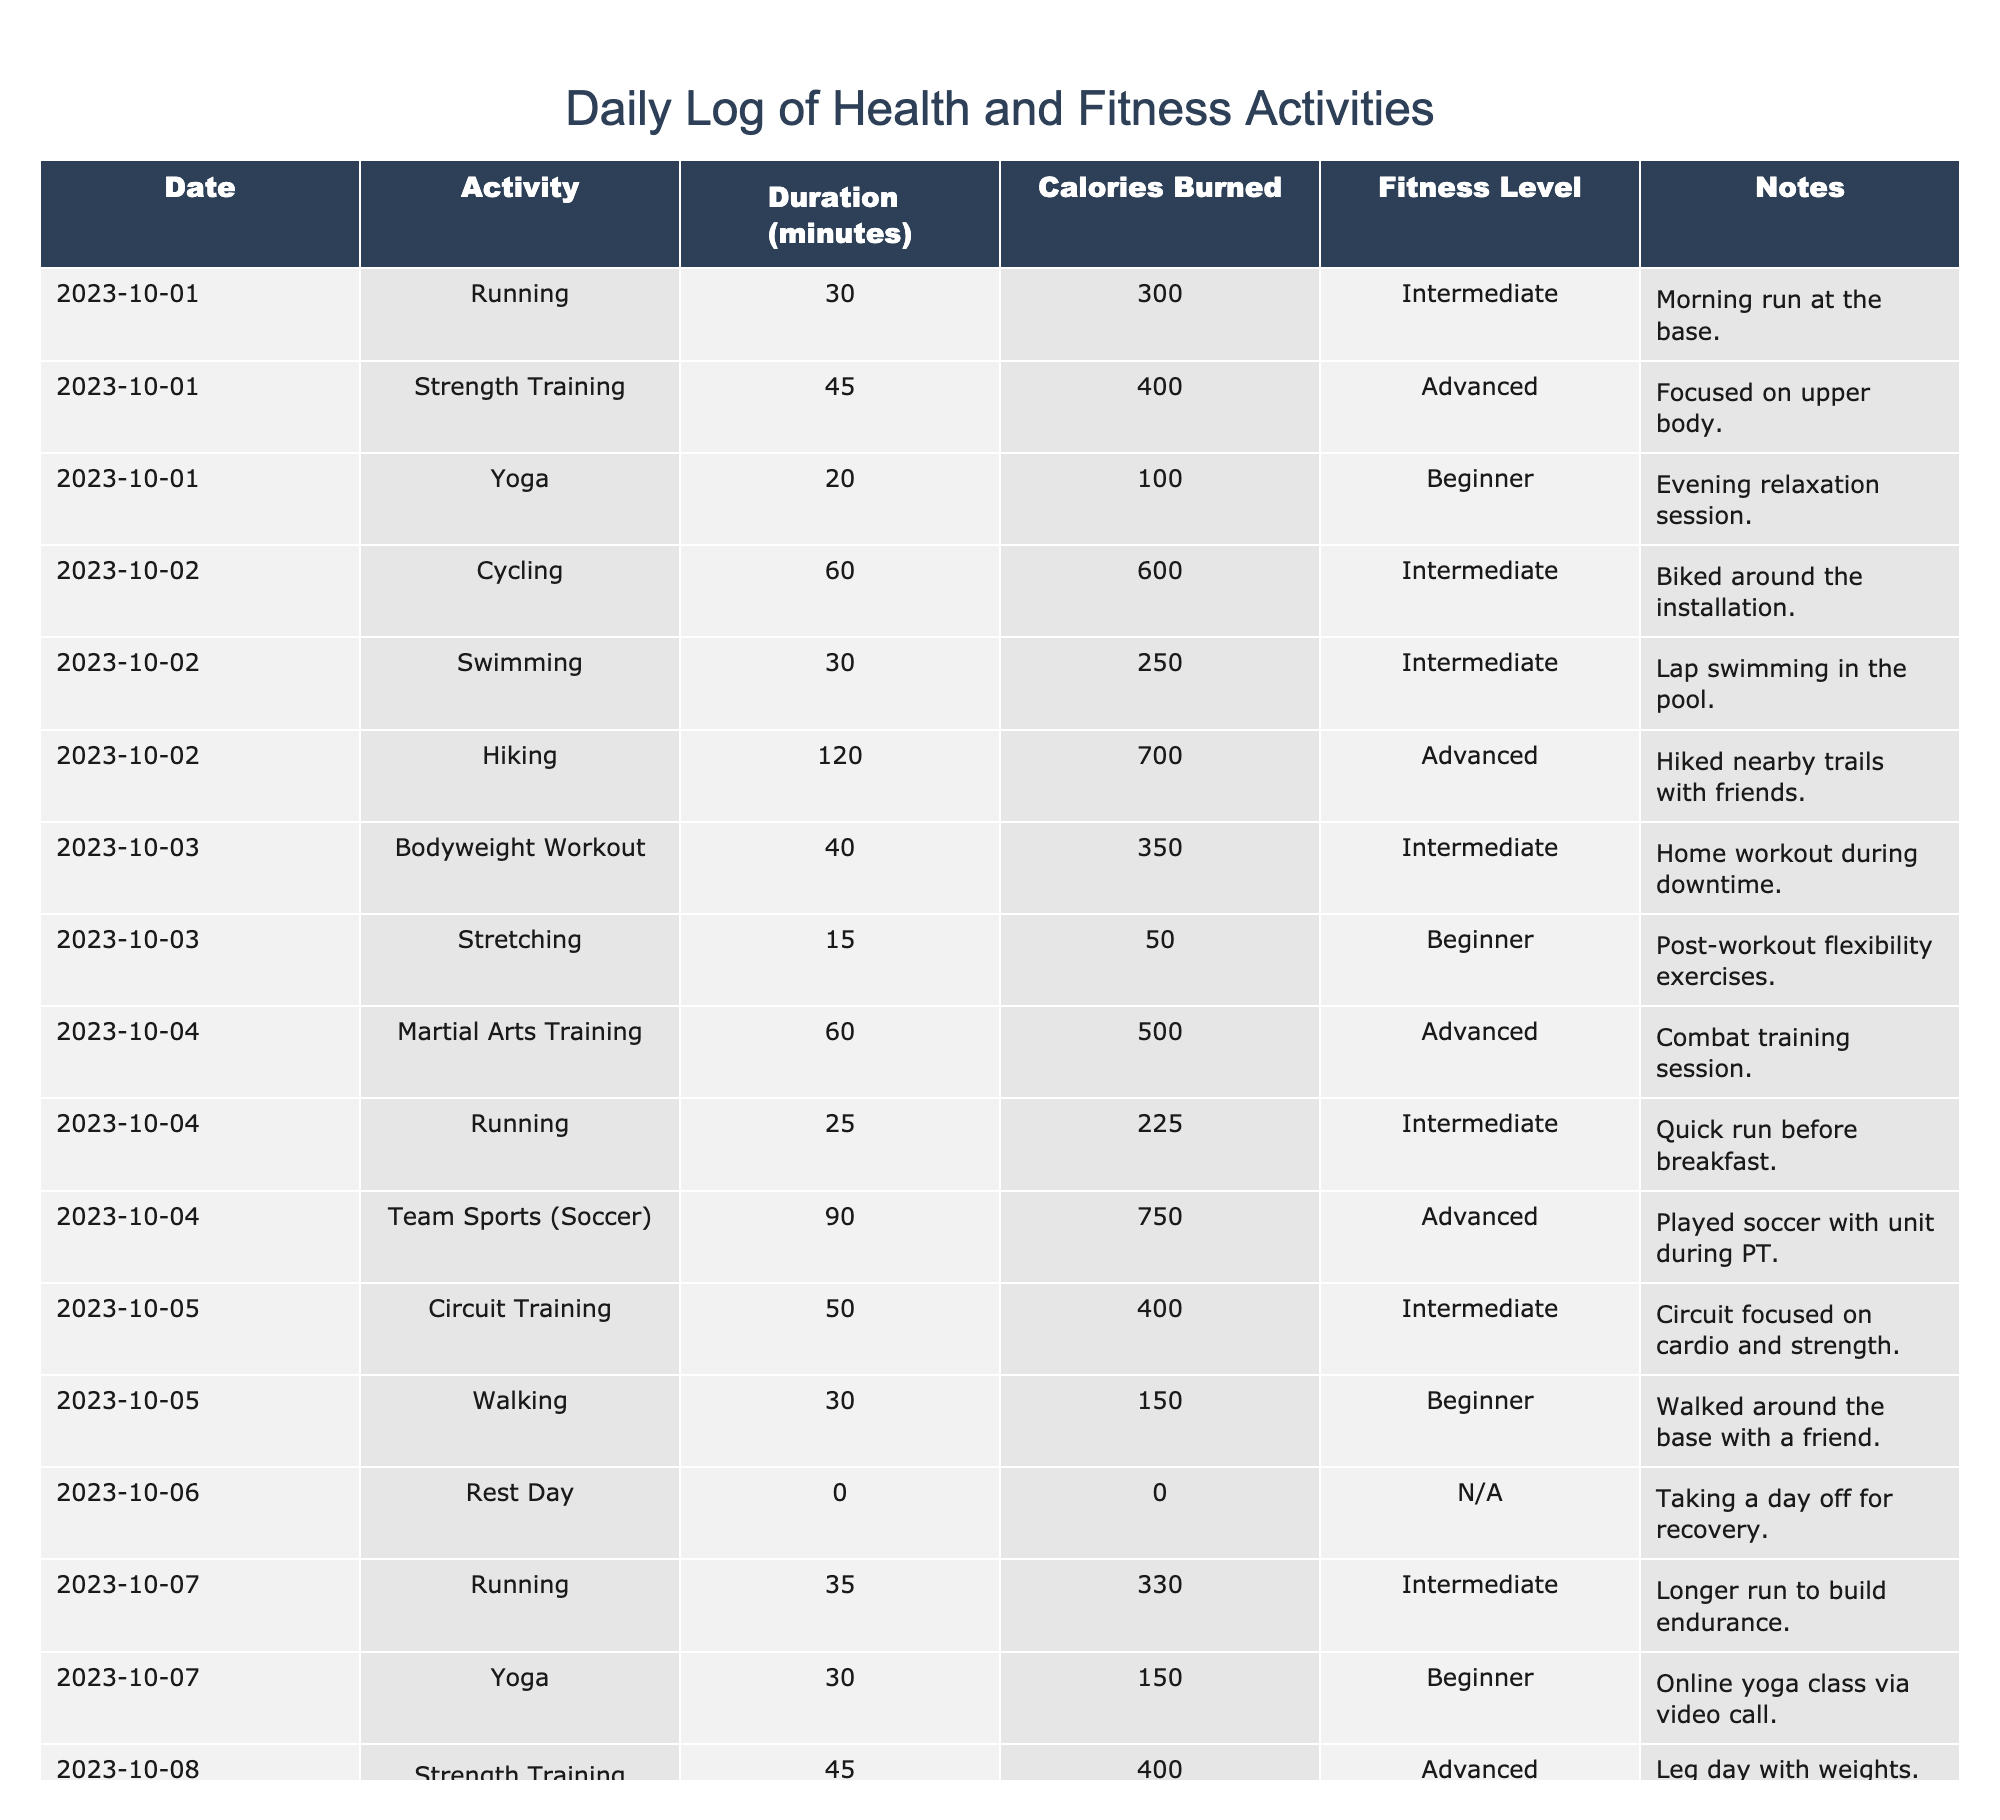What activity had the highest calories burned in a single session? Looking through the table, the activity with the highest calories burned is "Team Sports (Soccer)" on 2023-10-04, which burned **750 calories**.
Answer: Soccer How many total minutes of activity were logged on 2023-10-02? On 2023-10-02, the activities logged include Cycling (60 minutes), Swimming (30 minutes), and Hiking (120 minutes). Adding these together gives 60 + 30 + 120 = 210 minutes.
Answer: 210 minutes Was there a rest day recorded? The table shows a rest day on 2023-10-06, where the duration was **0 minutes**. Therefore, yes, there is a rest day recorded.
Answer: Yes What was the average calories burned per activity on the days logged? The total calories burned across all activities is (300 + 400 + 100 + 600 + 250 + 700 + 350 + 50 + 500 + 225 + 750 + 400 + 150 + 0 + 350) = 4,825 calories. There are 15 activities, thus the average is 4,825 / 15 = approximately 321.67 calories per activity.
Answer: 321.67 Which type of activity is repeated most frequently over the logged days? The activities logged most frequently include running, which appears **four times** on 2023-10-01, 2023-10-04, and 2023-10-07.
Answer: Running What is the total duration of strength training activities? The table shows strength training on 2023-10-01 (45 minutes) and lower body strength training on 2023-10-08 (45 minutes). Adding these gives 45 + 45 = 90 minutes of strength training.
Answer: 90 minutes On which day did the most activities occur and how many were there? The day with the most activities is 2023-10-02, which had **three activities** logged: Cycling, Swimming, and Hiking.
Answer: 3 activities How many activities were categorized as Advanced fitness level? In the table, there are **five activities** categorized as Advanced: Strength Training, Hiking, Martial Arts Training, Team Sports (Soccer), and Strength Training (Lower Body).
Answer: 5 activities What was the total calories burned from all activities on 2023-10-04? On 2023-10-04, the activities logged were Martial Arts Training (500 calories), Running (225 calories), and Team Sports (Soccer) (750 calories). Adding these gives 500 + 225 + 750 = 1,475 calories burned that day.
Answer: 1,475 calories Did any days have activities marked as N/A in the fitness level? Yes, on 2023-10-08, a Family Video Call activity is marked as N/A for fitness level.
Answer: Yes 